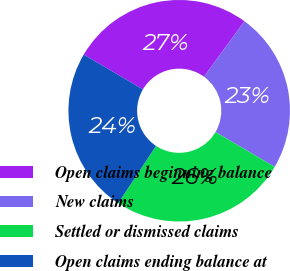<chart> <loc_0><loc_0><loc_500><loc_500><pie_chart><fcel>Open claims beginning balance<fcel>New claims<fcel>Settled or dismissed claims<fcel>Open claims ending balance at<nl><fcel>26.56%<fcel>23.44%<fcel>25.82%<fcel>24.18%<nl></chart> 